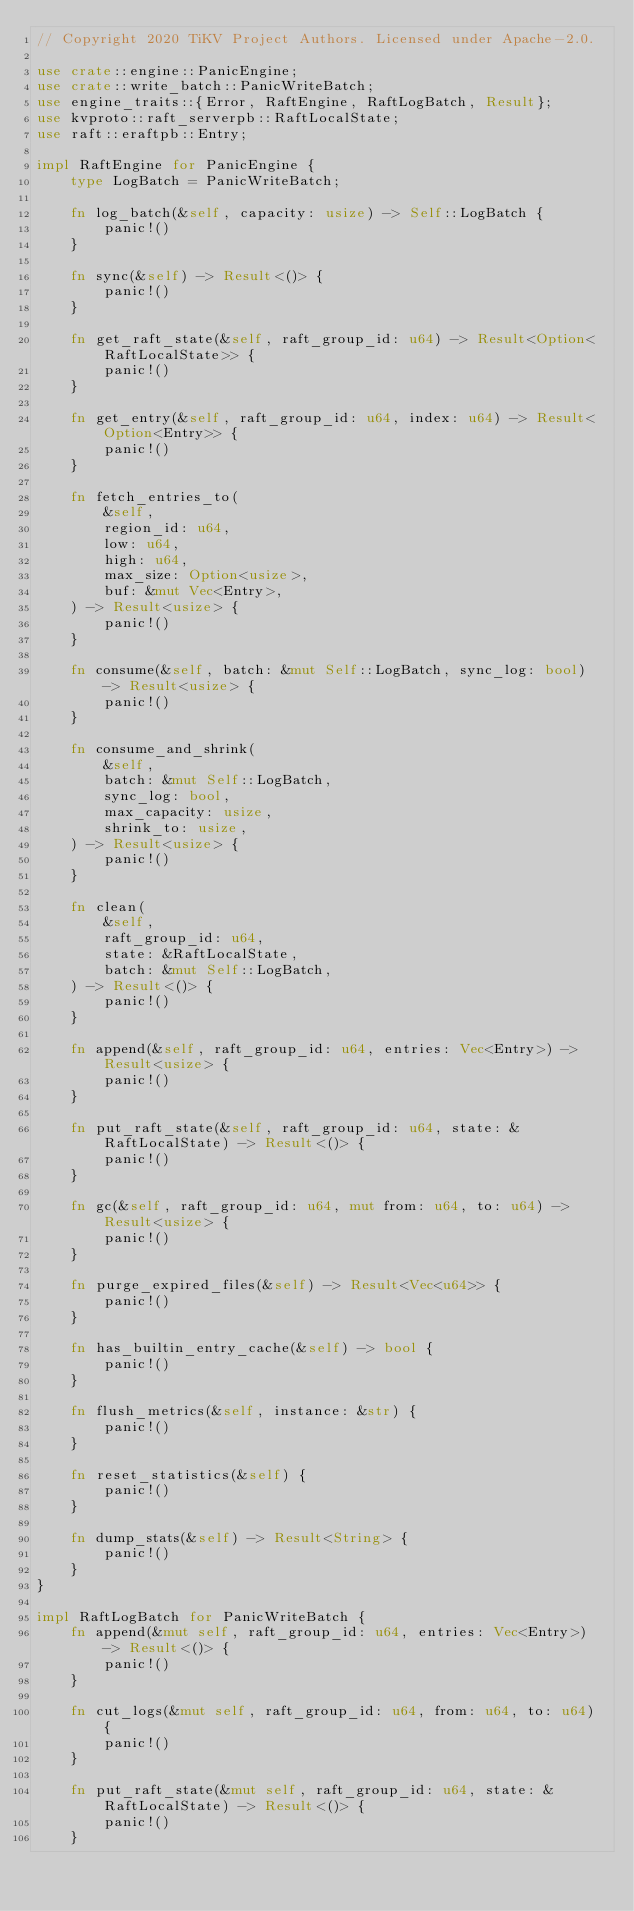<code> <loc_0><loc_0><loc_500><loc_500><_Rust_>// Copyright 2020 TiKV Project Authors. Licensed under Apache-2.0.

use crate::engine::PanicEngine;
use crate::write_batch::PanicWriteBatch;
use engine_traits::{Error, RaftEngine, RaftLogBatch, Result};
use kvproto::raft_serverpb::RaftLocalState;
use raft::eraftpb::Entry;

impl RaftEngine for PanicEngine {
    type LogBatch = PanicWriteBatch;

    fn log_batch(&self, capacity: usize) -> Self::LogBatch {
        panic!()
    }

    fn sync(&self) -> Result<()> {
        panic!()
    }

    fn get_raft_state(&self, raft_group_id: u64) -> Result<Option<RaftLocalState>> {
        panic!()
    }

    fn get_entry(&self, raft_group_id: u64, index: u64) -> Result<Option<Entry>> {
        panic!()
    }

    fn fetch_entries_to(
        &self,
        region_id: u64,
        low: u64,
        high: u64,
        max_size: Option<usize>,
        buf: &mut Vec<Entry>,
    ) -> Result<usize> {
        panic!()
    }

    fn consume(&self, batch: &mut Self::LogBatch, sync_log: bool) -> Result<usize> {
        panic!()
    }

    fn consume_and_shrink(
        &self,
        batch: &mut Self::LogBatch,
        sync_log: bool,
        max_capacity: usize,
        shrink_to: usize,
    ) -> Result<usize> {
        panic!()
    }

    fn clean(
        &self,
        raft_group_id: u64,
        state: &RaftLocalState,
        batch: &mut Self::LogBatch,
    ) -> Result<()> {
        panic!()
    }

    fn append(&self, raft_group_id: u64, entries: Vec<Entry>) -> Result<usize> {
        panic!()
    }

    fn put_raft_state(&self, raft_group_id: u64, state: &RaftLocalState) -> Result<()> {
        panic!()
    }

    fn gc(&self, raft_group_id: u64, mut from: u64, to: u64) -> Result<usize> {
        panic!()
    }

    fn purge_expired_files(&self) -> Result<Vec<u64>> {
        panic!()
    }

    fn has_builtin_entry_cache(&self) -> bool {
        panic!()
    }

    fn flush_metrics(&self, instance: &str) {
        panic!()
    }

    fn reset_statistics(&self) {
        panic!()
    }

    fn dump_stats(&self) -> Result<String> {
        panic!()
    }
}

impl RaftLogBatch for PanicWriteBatch {
    fn append(&mut self, raft_group_id: u64, entries: Vec<Entry>) -> Result<()> {
        panic!()
    }

    fn cut_logs(&mut self, raft_group_id: u64, from: u64, to: u64) {
        panic!()
    }

    fn put_raft_state(&mut self, raft_group_id: u64, state: &RaftLocalState) -> Result<()> {
        panic!()
    }
</code> 